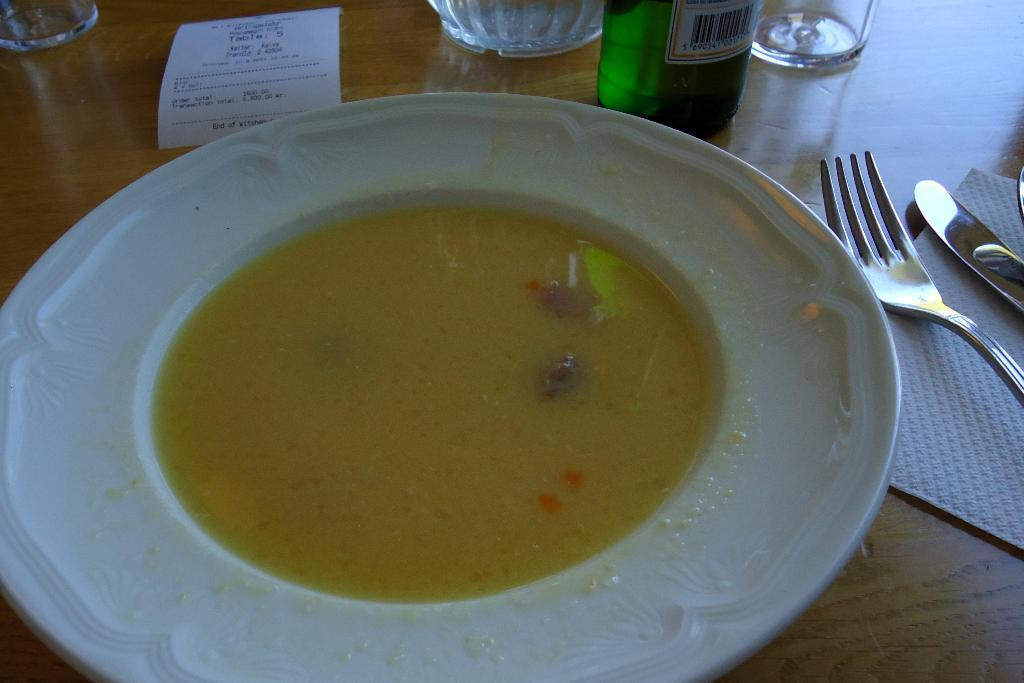What type of food is in the plate in the image? There is soup in a white color plate. What other items can be seen on the table in the image? There are bottles, glasses, a spoon, a fork, and tissue paper on the table. How many eyes can be seen on the pig in the image? There is no pig present in the image, so it is not possible to determine the number of eyes on a pig. 